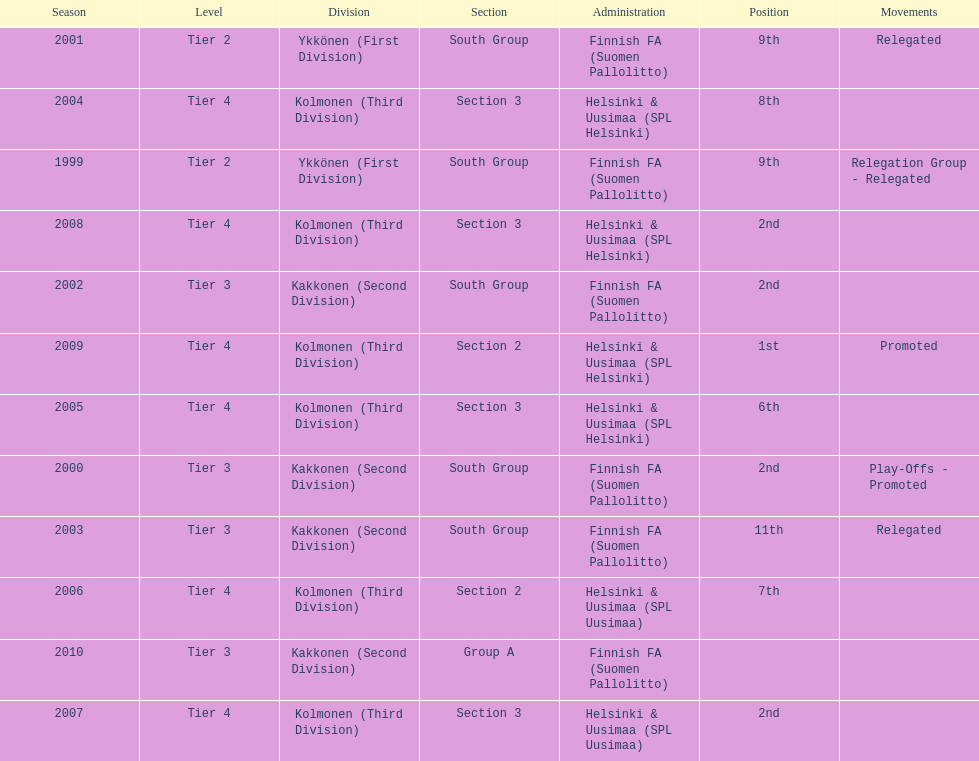How many 2nd positions were there? 4. I'm looking to parse the entire table for insights. Could you assist me with that? {'header': ['Season', 'Level', 'Division', 'Section', 'Administration', 'Position', 'Movements'], 'rows': [['2001', 'Tier 2', 'Ykkönen (First Division)', 'South Group', 'Finnish FA (Suomen Pallolitto)', '9th', 'Relegated'], ['2004', 'Tier 4', 'Kolmonen (Third Division)', 'Section 3', 'Helsinki & Uusimaa (SPL Helsinki)', '8th', ''], ['1999', 'Tier 2', 'Ykkönen (First Division)', 'South Group', 'Finnish FA (Suomen Pallolitto)', '9th', 'Relegation Group - Relegated'], ['2008', 'Tier 4', 'Kolmonen (Third Division)', 'Section 3', 'Helsinki & Uusimaa (SPL Helsinki)', '2nd', ''], ['2002', 'Tier 3', 'Kakkonen (Second Division)', 'South Group', 'Finnish FA (Suomen Pallolitto)', '2nd', ''], ['2009', 'Tier 4', 'Kolmonen (Third Division)', 'Section 2', 'Helsinki & Uusimaa (SPL Helsinki)', '1st', 'Promoted'], ['2005', 'Tier 4', 'Kolmonen (Third Division)', 'Section 3', 'Helsinki & Uusimaa (SPL Helsinki)', '6th', ''], ['2000', 'Tier 3', 'Kakkonen (Second Division)', 'South Group', 'Finnish FA (Suomen Pallolitto)', '2nd', 'Play-Offs - Promoted'], ['2003', 'Tier 3', 'Kakkonen (Second Division)', 'South Group', 'Finnish FA (Suomen Pallolitto)', '11th', 'Relegated'], ['2006', 'Tier 4', 'Kolmonen (Third Division)', 'Section 2', 'Helsinki & Uusimaa (SPL Uusimaa)', '7th', ''], ['2010', 'Tier 3', 'Kakkonen (Second Division)', 'Group A', 'Finnish FA (Suomen Pallolitto)', '', ''], ['2007', 'Tier 4', 'Kolmonen (Third Division)', 'Section 3', 'Helsinki & Uusimaa (SPL Uusimaa)', '2nd', '']]} 